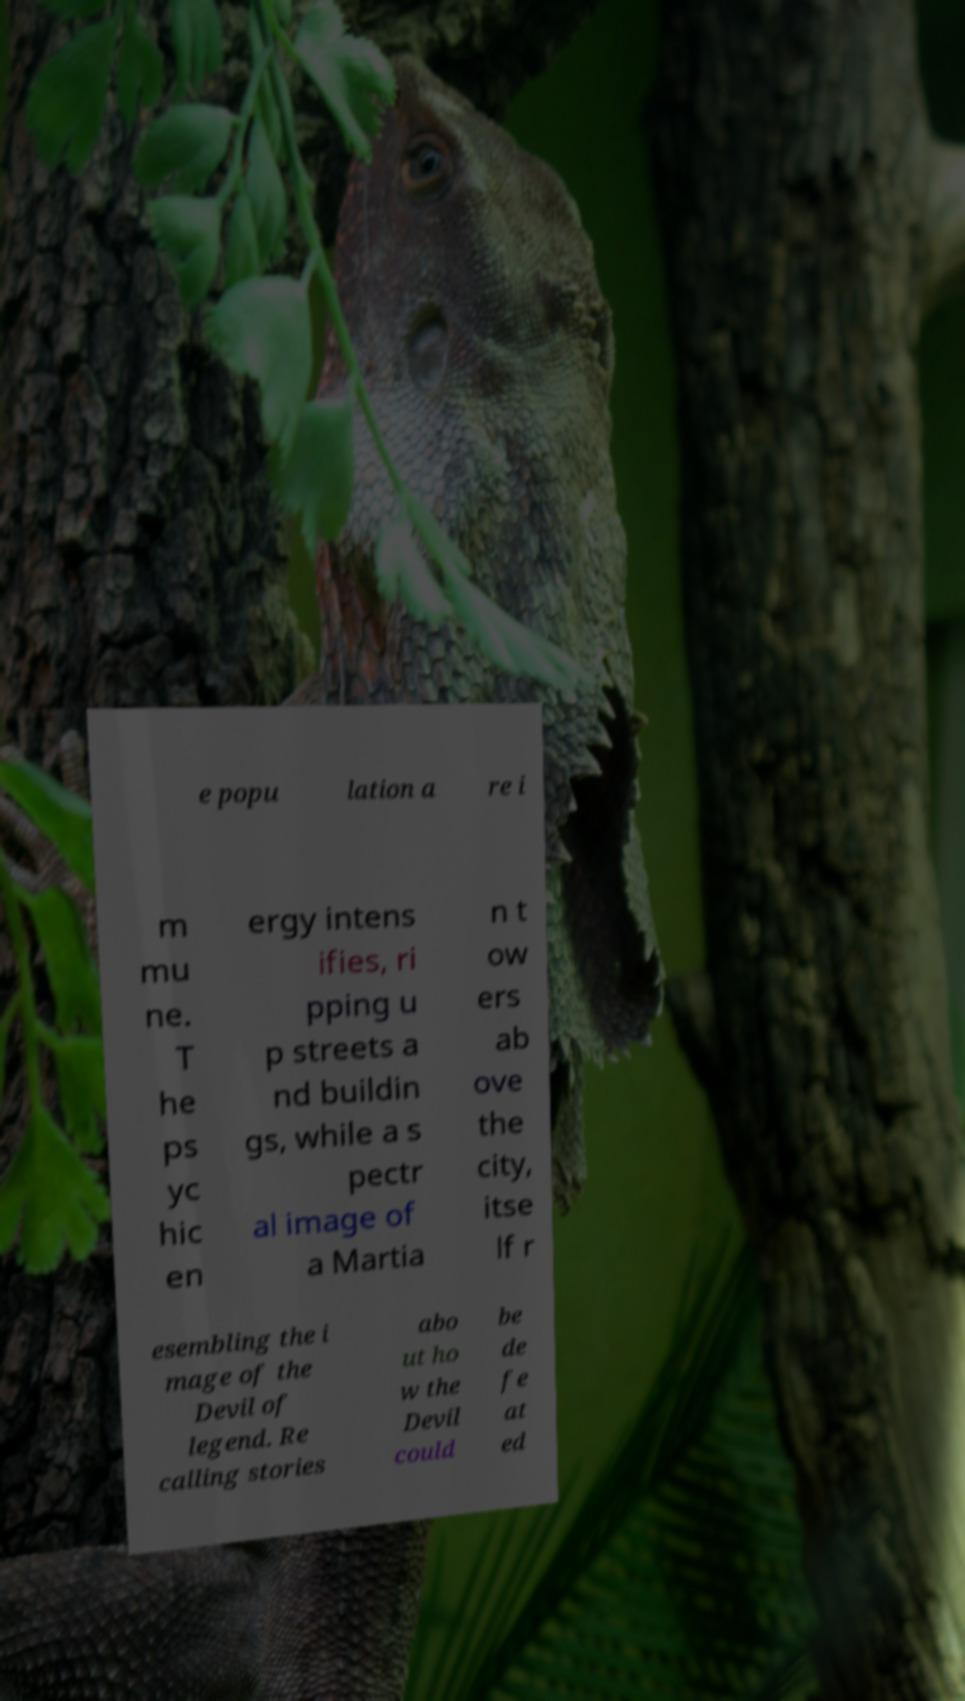For documentation purposes, I need the text within this image transcribed. Could you provide that? e popu lation a re i m mu ne. T he ps yc hic en ergy intens ifies, ri pping u p streets a nd buildin gs, while a s pectr al image of a Martia n t ow ers ab ove the city, itse lf r esembling the i mage of the Devil of legend. Re calling stories abo ut ho w the Devil could be de fe at ed 